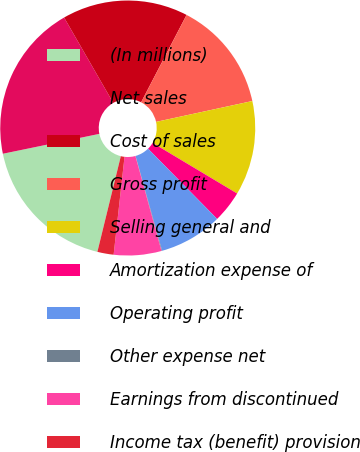Convert chart to OTSL. <chart><loc_0><loc_0><loc_500><loc_500><pie_chart><fcel>(In millions)<fcel>Net sales<fcel>Cost of sales<fcel>Gross profit<fcel>Selling general and<fcel>Amortization expense of<fcel>Operating profit<fcel>Other expense net<fcel>Earnings from discontinued<fcel>Income tax (benefit) provision<nl><fcel>17.94%<fcel>19.92%<fcel>15.95%<fcel>13.97%<fcel>11.98%<fcel>4.05%<fcel>8.02%<fcel>0.08%<fcel>6.03%<fcel>2.06%<nl></chart> 